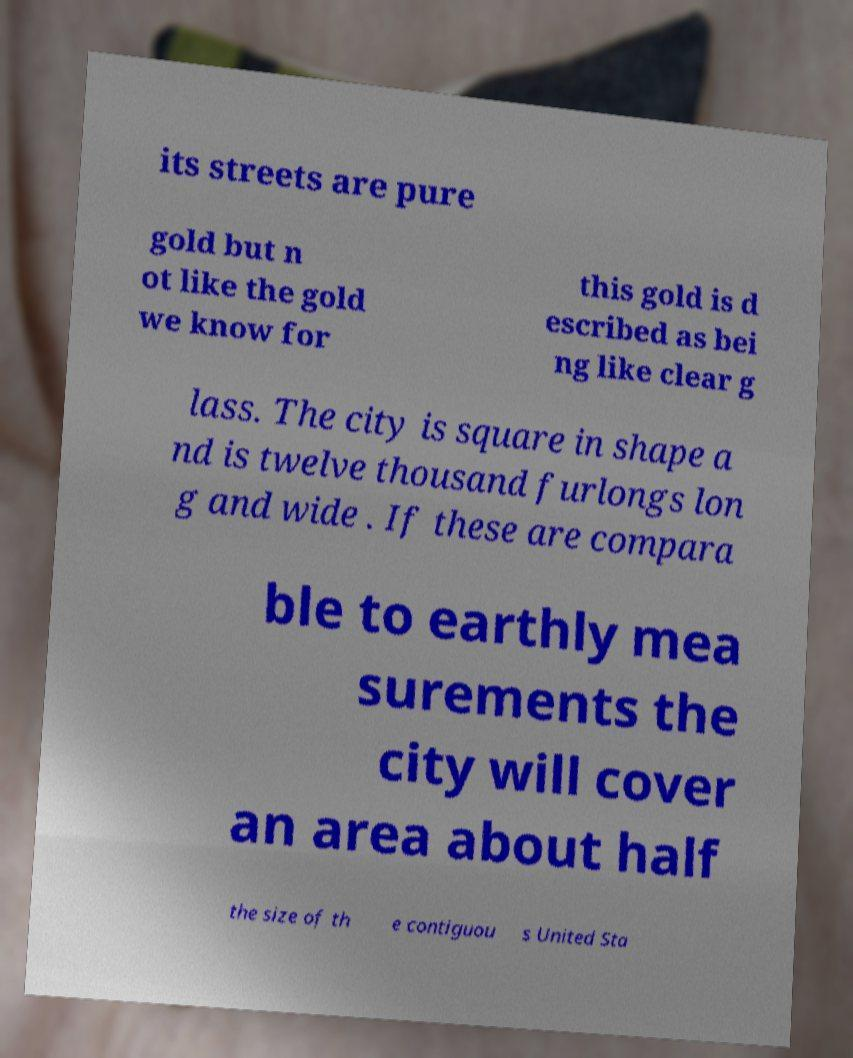Can you accurately transcribe the text from the provided image for me? its streets are pure gold but n ot like the gold we know for this gold is d escribed as bei ng like clear g lass. The city is square in shape a nd is twelve thousand furlongs lon g and wide . If these are compara ble to earthly mea surements the city will cover an area about half the size of th e contiguou s United Sta 